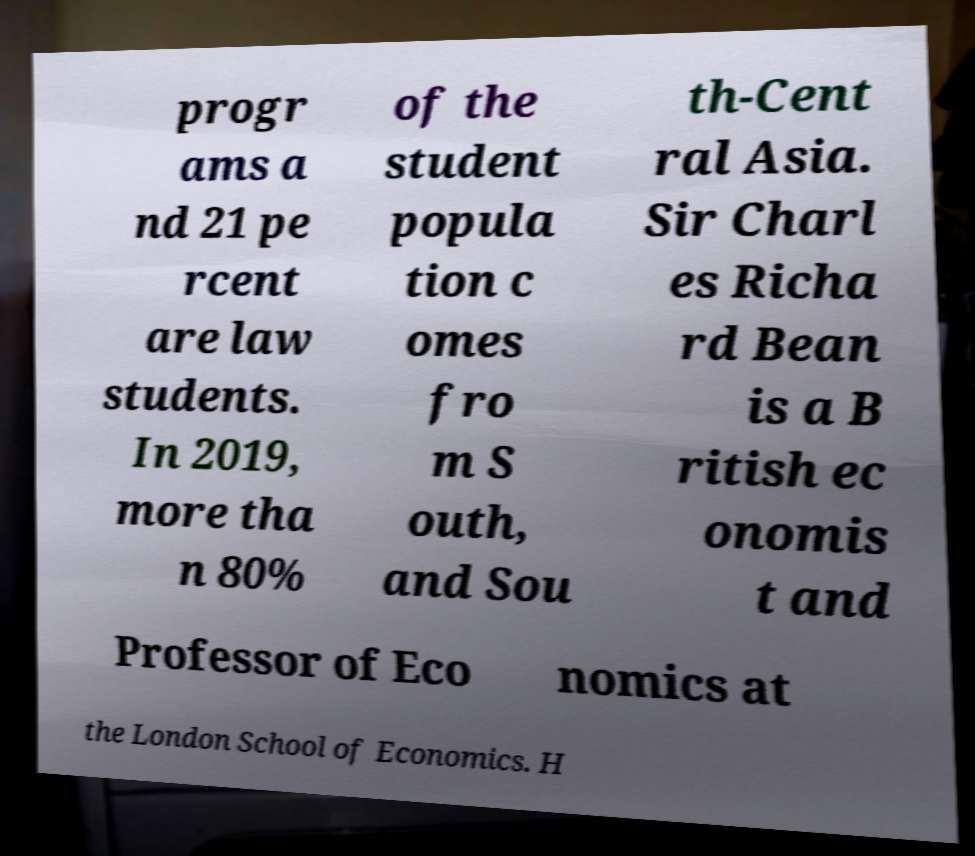For documentation purposes, I need the text within this image transcribed. Could you provide that? progr ams a nd 21 pe rcent are law students. In 2019, more tha n 80% of the student popula tion c omes fro m S outh, and Sou th-Cent ral Asia. Sir Charl es Richa rd Bean is a B ritish ec onomis t and Professor of Eco nomics at the London School of Economics. H 